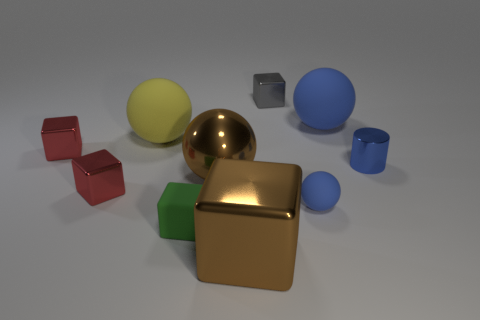There is a tiny red object in front of the small blue metal cylinder; how many cubes are to the right of it?
Keep it short and to the point. 3. Are there more big rubber cylinders than gray shiny cubes?
Provide a short and direct response. No. Is the tiny gray block made of the same material as the small green block?
Give a very brief answer. No. Are there an equal number of shiny things that are to the right of the big brown cube and tiny blue metallic cylinders?
Your answer should be compact. No. What number of things are the same material as the cylinder?
Provide a short and direct response. 5. Is the number of small gray shiny blocks less than the number of small purple matte objects?
Offer a very short reply. No. Do the large thing that is on the right side of the gray shiny block and the small sphere have the same color?
Your answer should be very brief. Yes. What number of metallic balls are right of the red metallic thing behind the shiny thing on the right side of the gray object?
Your response must be concise. 1. There is a big yellow matte thing; how many blue objects are in front of it?
Provide a short and direct response. 2. There is another shiny object that is the same shape as the big blue object; what color is it?
Your answer should be compact. Brown. 